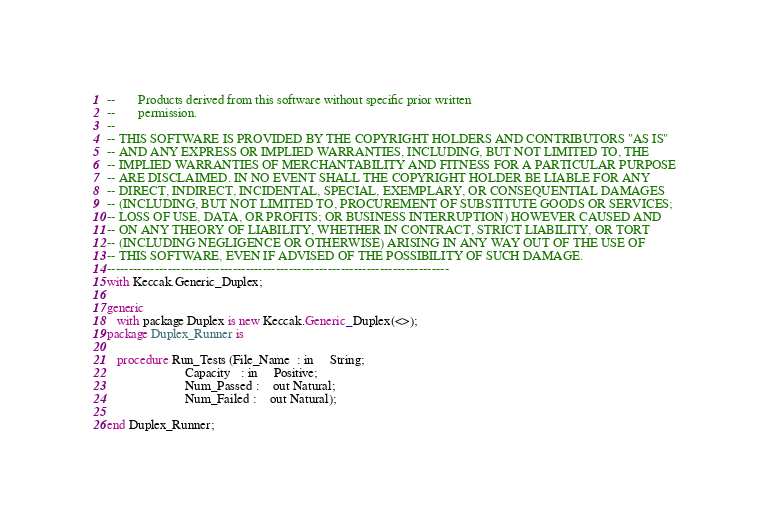Convert code to text. <code><loc_0><loc_0><loc_500><loc_500><_Ada_>--       Products derived from this software without specific prior written
--       permission.
--
-- THIS SOFTWARE IS PROVIDED BY THE COPYRIGHT HOLDERS AND CONTRIBUTORS "AS IS"
-- AND ANY EXPRESS OR IMPLIED WARRANTIES, INCLUDING, BUT NOT LIMITED TO, THE
-- IMPLIED WARRANTIES OF MERCHANTABILITY AND FITNESS FOR A PARTICULAR PURPOSE
-- ARE DISCLAIMED. IN NO EVENT SHALL THE COPYRIGHT HOLDER BE LIABLE FOR ANY
-- DIRECT, INDIRECT, INCIDENTAL, SPECIAL, EXEMPLARY, OR CONSEQUENTIAL DAMAGES
-- (INCLUDING, BUT NOT LIMITED TO, PROCUREMENT OF SUBSTITUTE GOODS OR SERVICES;
-- LOSS OF USE, DATA, OR PROFITS; OR BUSINESS INTERRUPTION) HOWEVER CAUSED AND
-- ON ANY THEORY OF LIABILITY, WHETHER IN CONTRACT, STRICT LIABILITY, OR TORT
-- (INCLUDING NEGLIGENCE OR OTHERWISE) ARISING IN ANY WAY OUT OF THE USE OF
-- THIS SOFTWARE, EVEN IF ADVISED OF THE POSSIBILITY OF SUCH DAMAGE.
-------------------------------------------------------------------------------
with Keccak.Generic_Duplex;

generic
   with package Duplex is new Keccak.Generic_Duplex(<>);
package Duplex_Runner is

   procedure Run_Tests (File_Name  : in     String;
                        Capacity   : in     Positive;
                        Num_Passed :    out Natural;
                        Num_Failed :    out Natural);

end Duplex_Runner;
</code> 